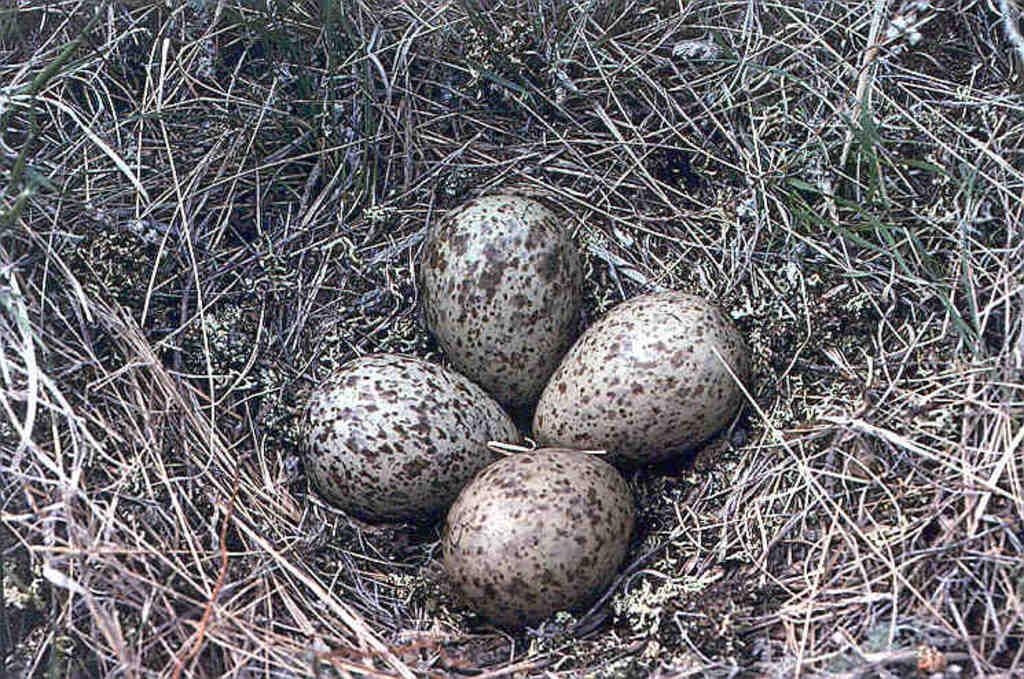Could you give a brief overview of what you see in this image? In this image I can see four eggs and grass. This image is taken during a day. 